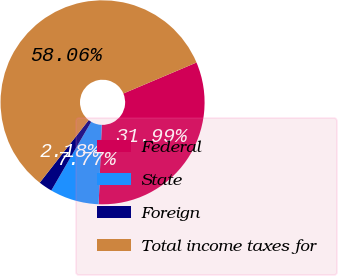Convert chart to OTSL. <chart><loc_0><loc_0><loc_500><loc_500><pie_chart><fcel>Federal<fcel>State<fcel>Foreign<fcel>Total income taxes for<nl><fcel>31.99%<fcel>7.77%<fcel>2.18%<fcel>58.06%<nl></chart> 